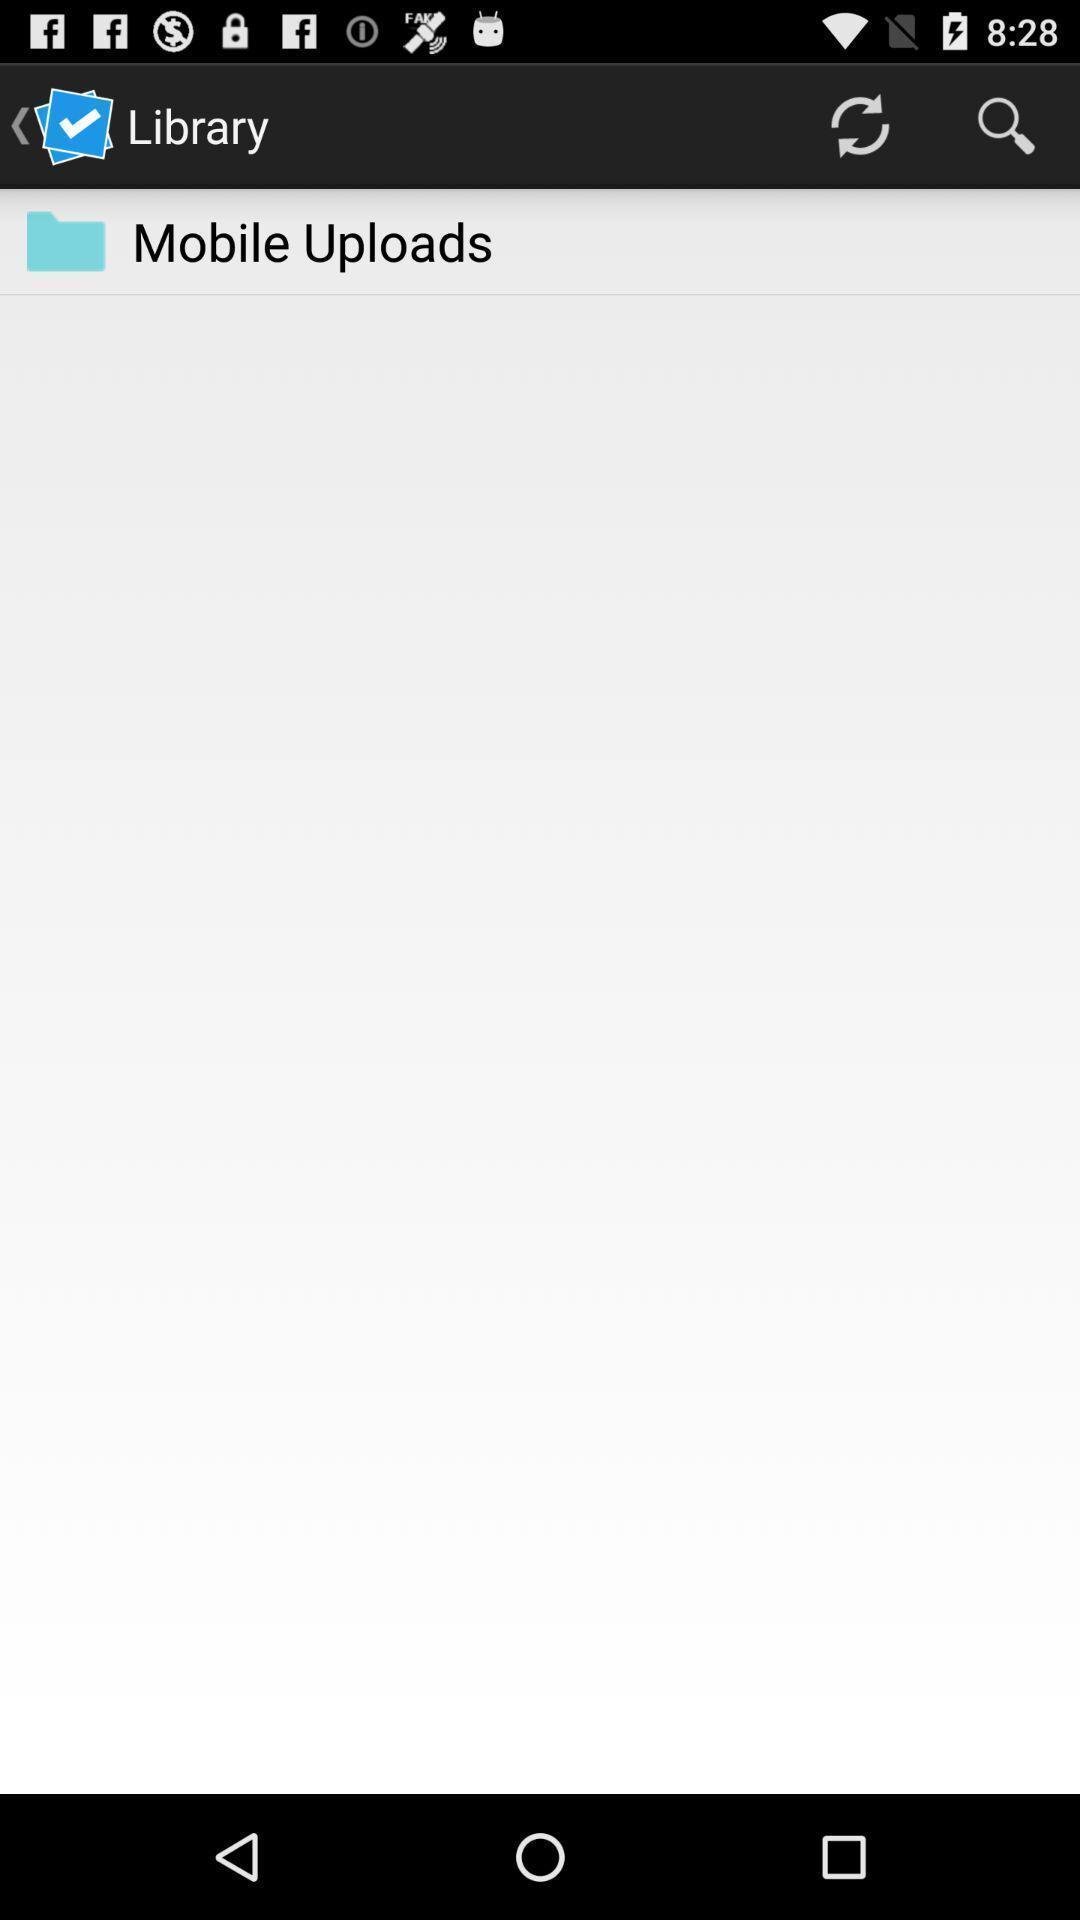Summarize the information in this screenshot. Screen page of a library files in a learning app. 